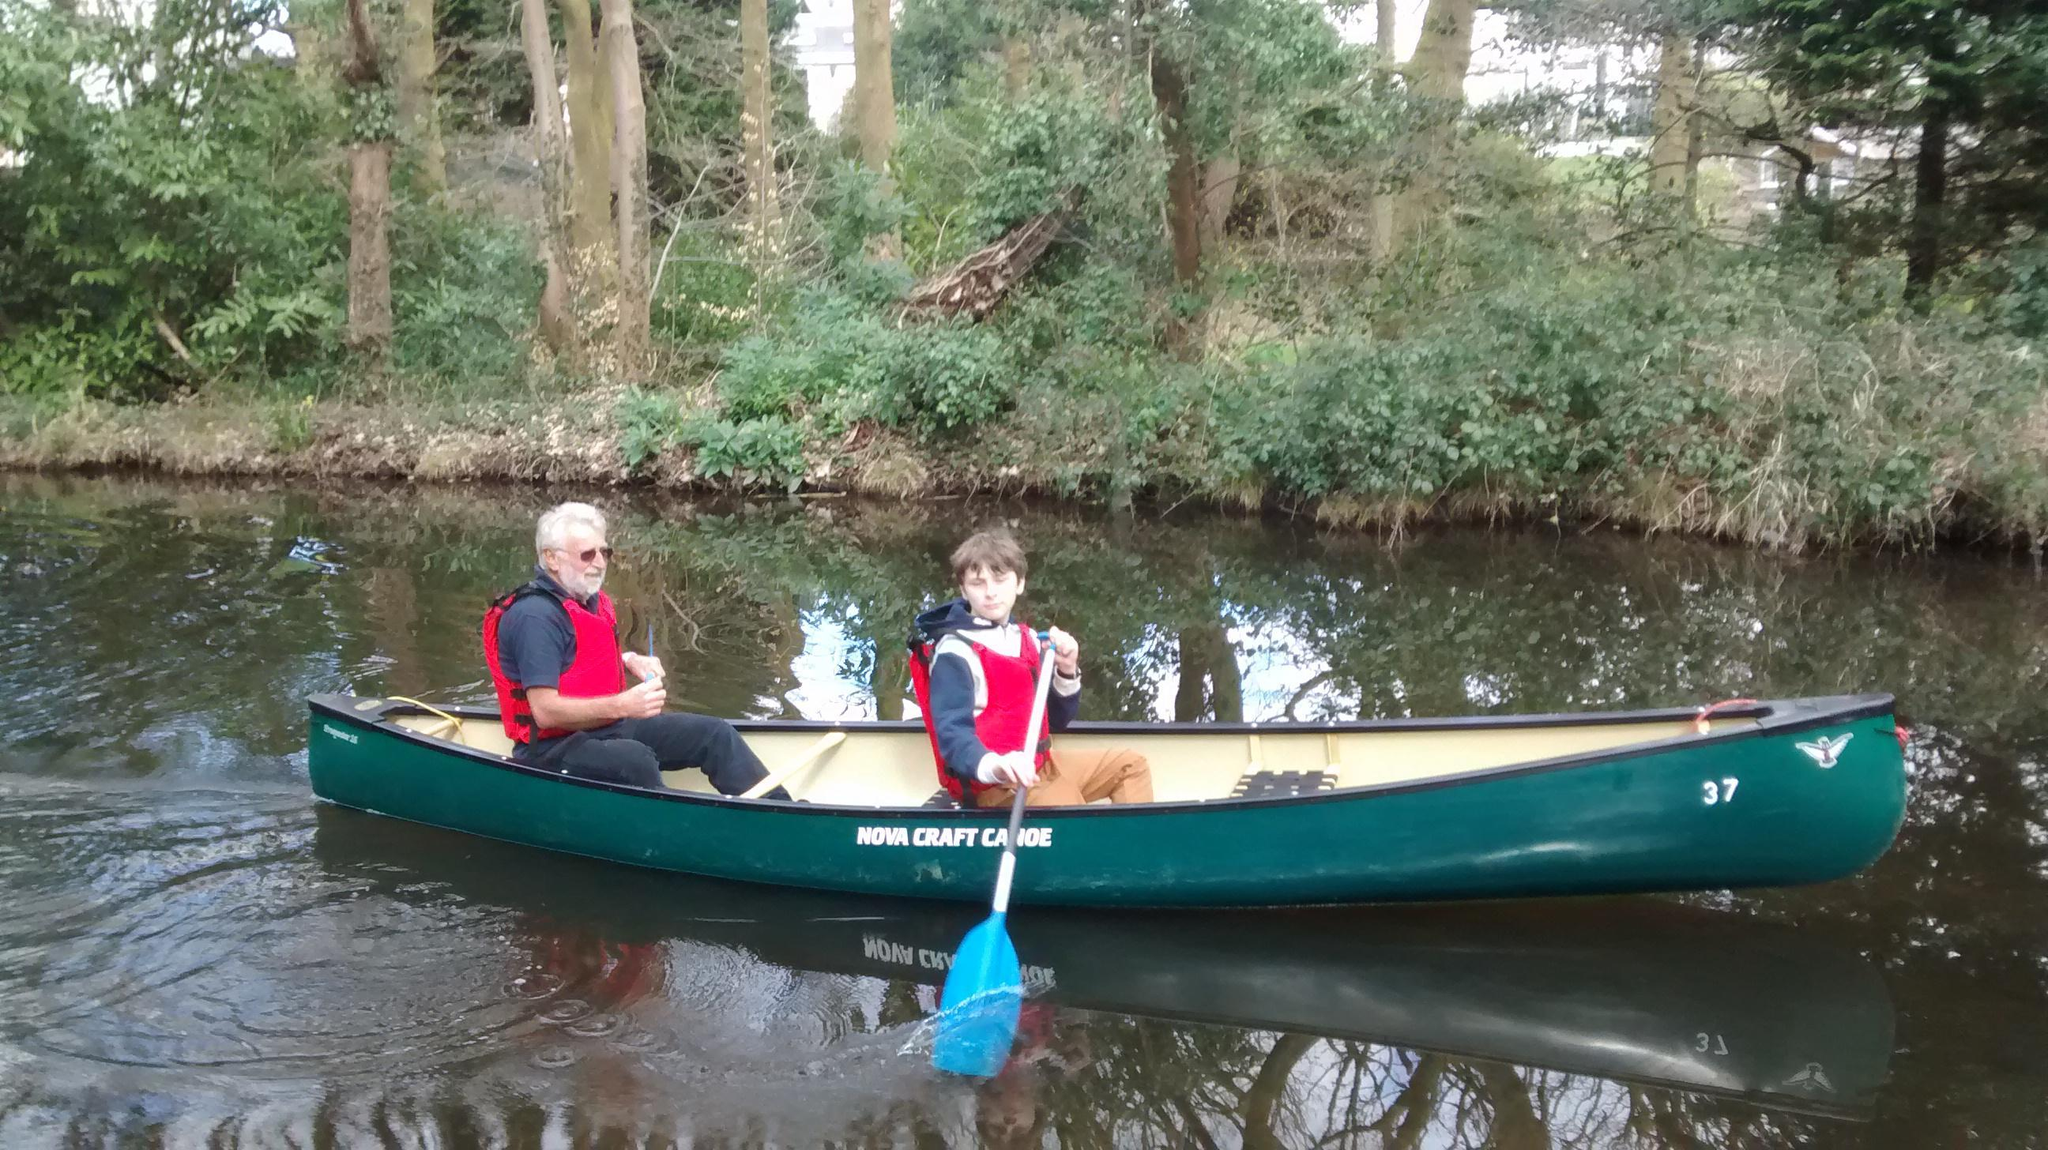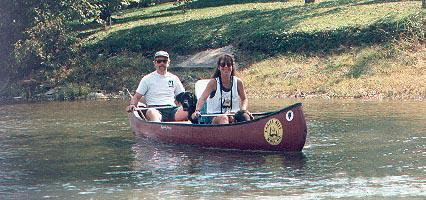The first image is the image on the left, the second image is the image on the right. Analyze the images presented: Is the assertion "there are exactly two people in the image on the right" valid? Answer yes or no. Yes. The first image is the image on the left, the second image is the image on the right. Assess this claim about the two images: "There's at least one yellow paddle shown.". Correct or not? Answer yes or no. No. 